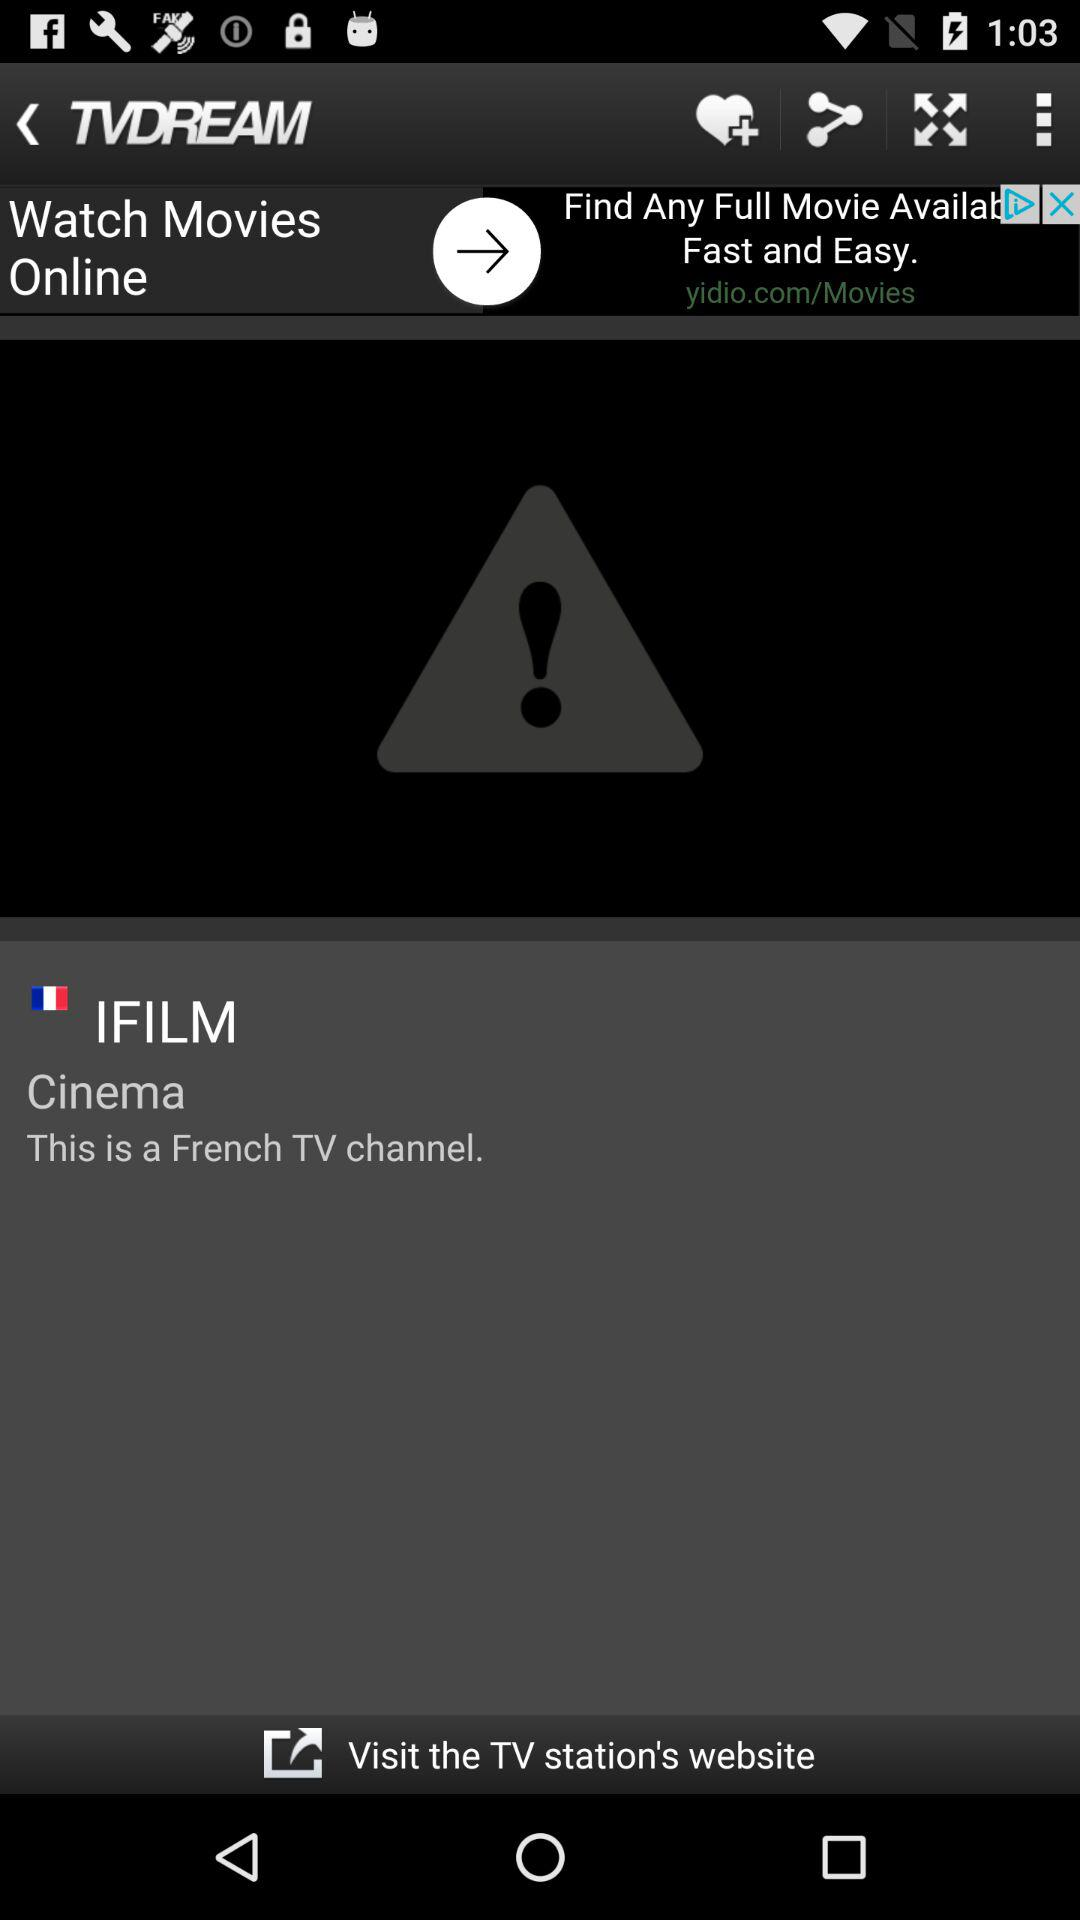What is the language of the shown TV channel? The language of the shown TV channel is French. 